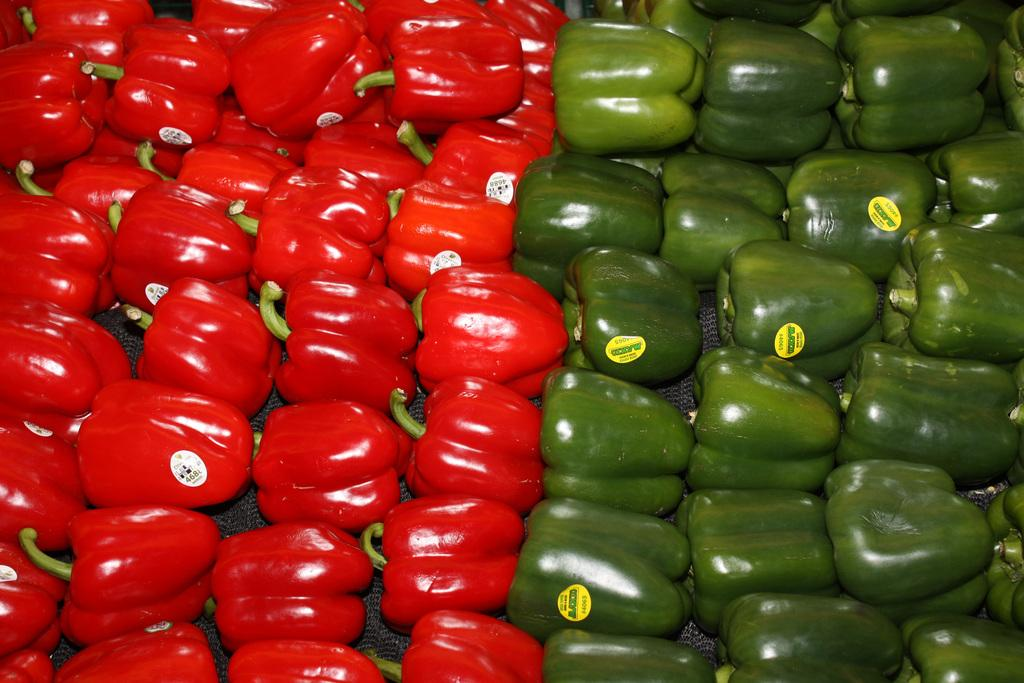What type of vegetables are present in the image? There are red and green capsicums in the image. What can be observed about the capsicums in the image? The capsicums have tags attached to them. What type of poison can be seen on the capsicums in the image? There is no poison present on the capsicums in the image. 